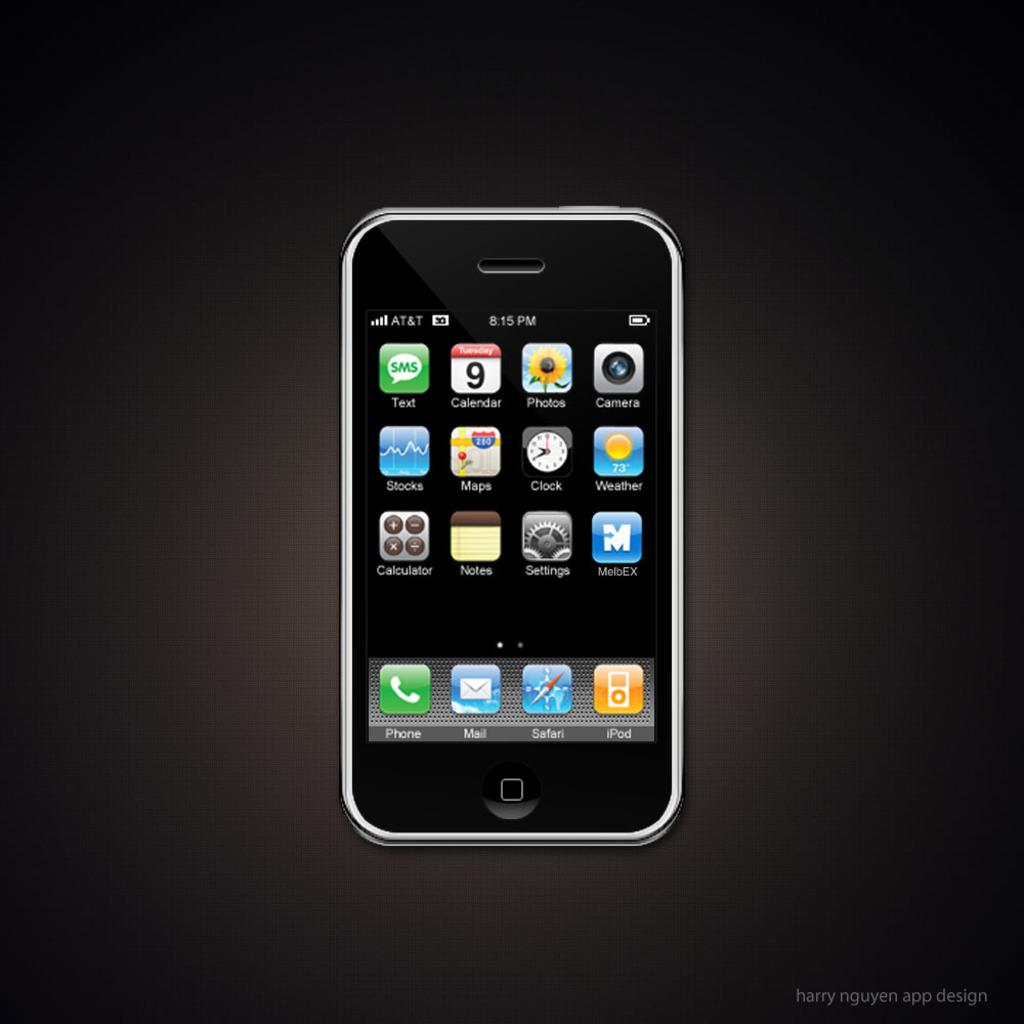<image>
Offer a succinct explanation of the picture presented. An AT&T phone on the main screen at 8:15pm 